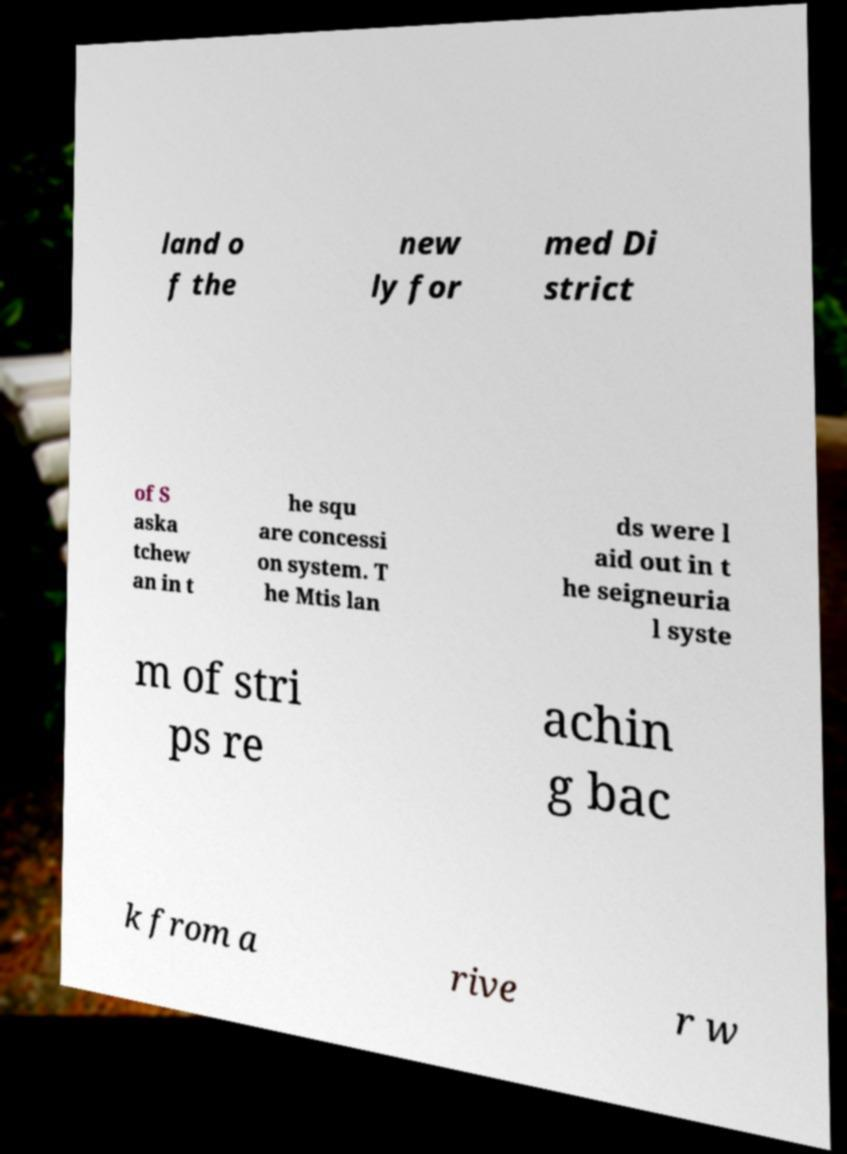Could you extract and type out the text from this image? land o f the new ly for med Di strict of S aska tchew an in t he squ are concessi on system. T he Mtis lan ds were l aid out in t he seigneuria l syste m of stri ps re achin g bac k from a rive r w 